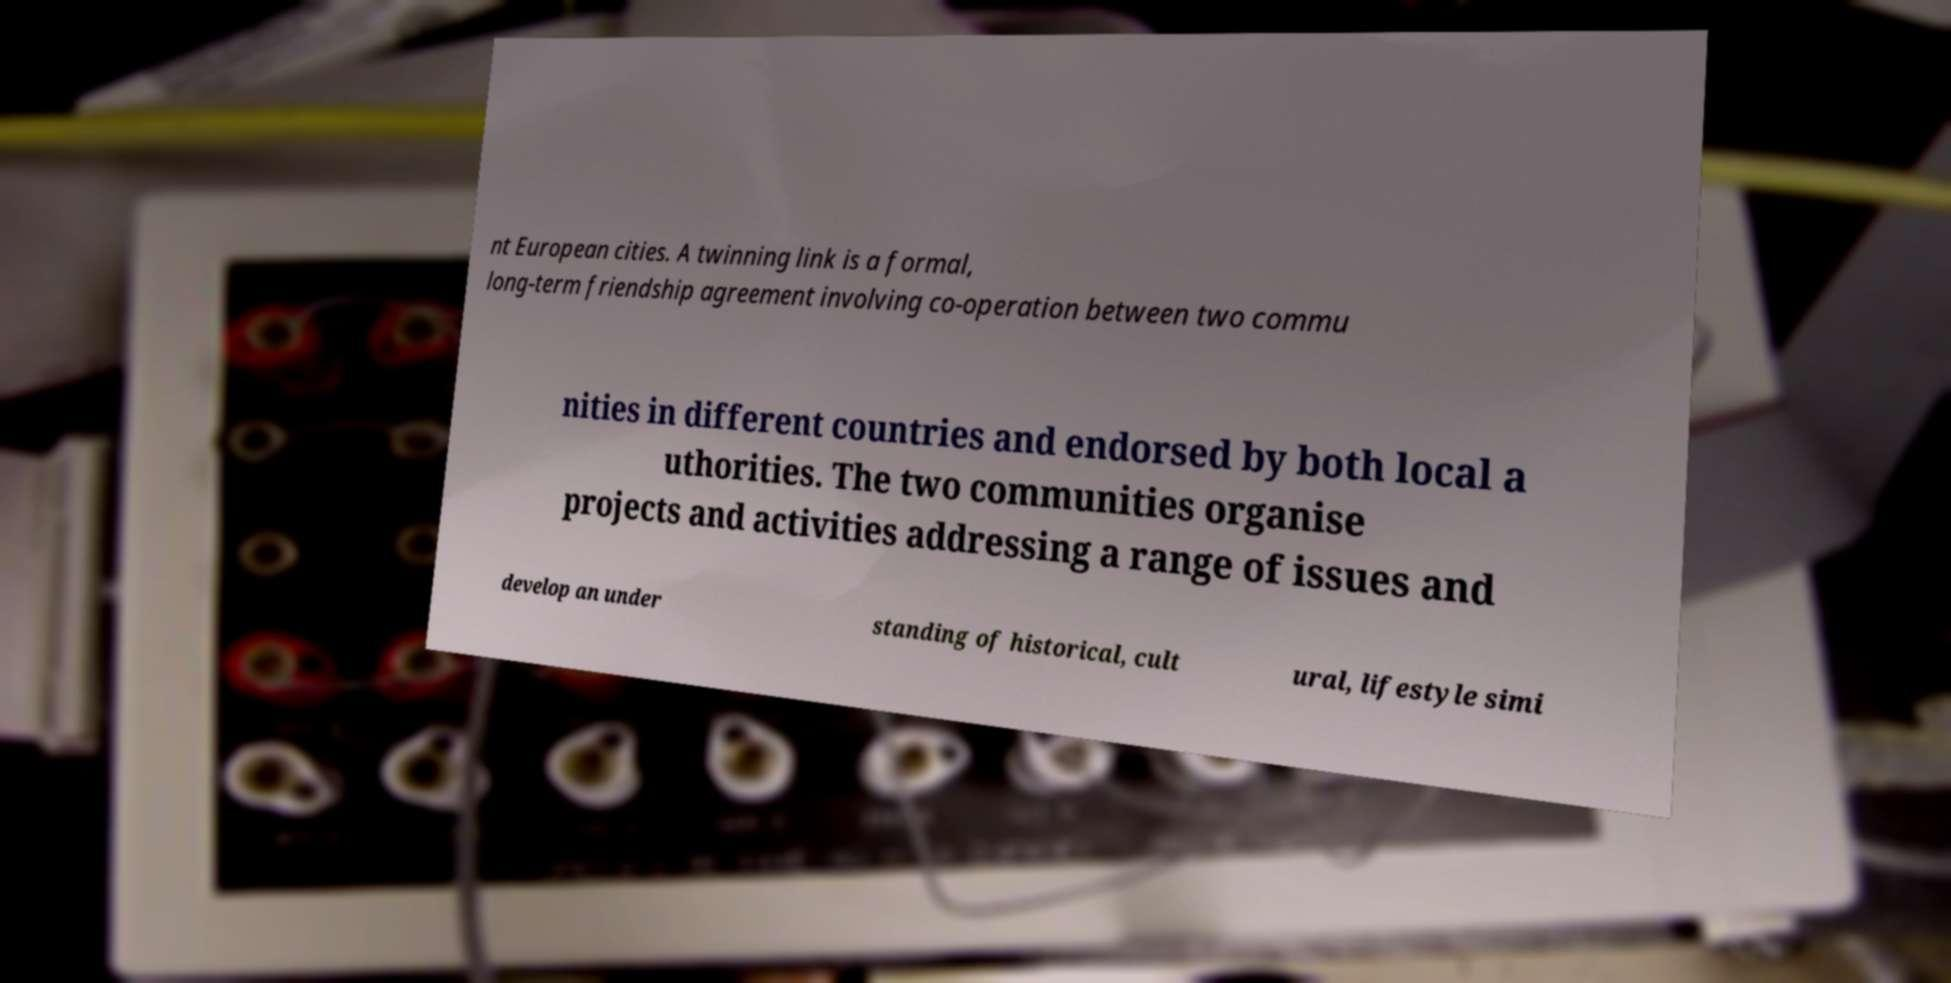What messages or text are displayed in this image? I need them in a readable, typed format. nt European cities. A twinning link is a formal, long-term friendship agreement involving co-operation between two commu nities in different countries and endorsed by both local a uthorities. The two communities organise projects and activities addressing a range of issues and develop an under standing of historical, cult ural, lifestyle simi 